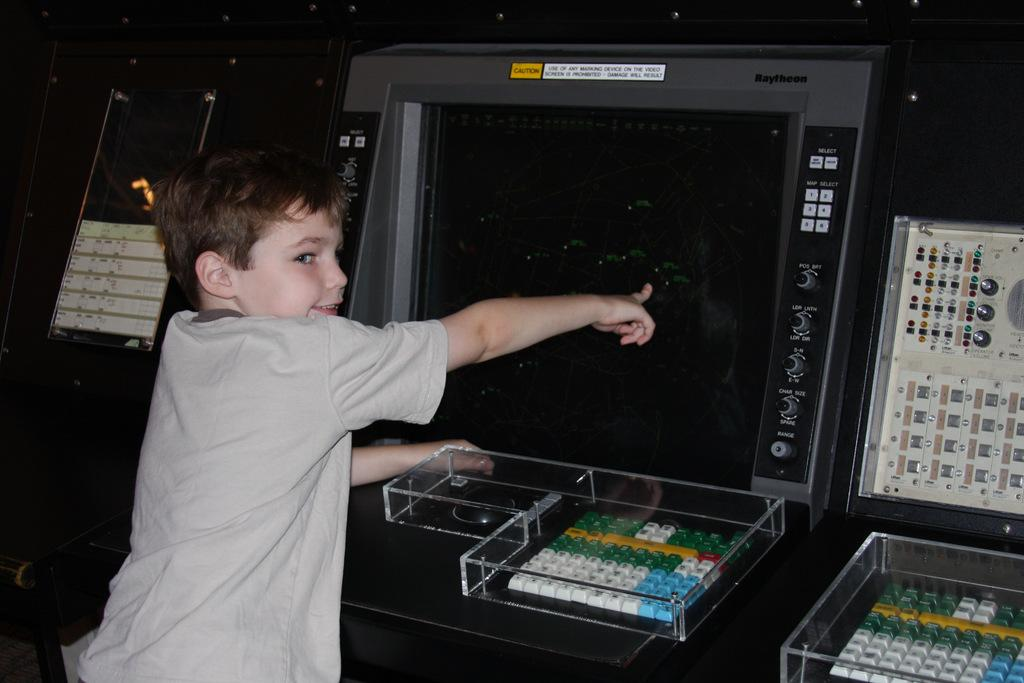What is the main subject of the image? There is a kid standing and smiling in the center of the image. What is in front of the kid? There are keyboards, boxes, a machine, and a few other objects in front of the kid. Can you describe the kid's expression? The kid is smiling in the image. How many geese are visible in the image? There are no geese present in the image. What type of sock is the kid wearing in the image? There is no sock visible in the image, as the kid is wearing shoes. 